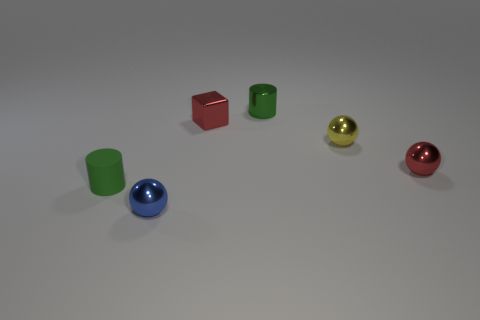Subtract all small red shiny balls. How many balls are left? 2 Add 4 red metallic spheres. How many objects exist? 10 Subtract 1 balls. How many balls are left? 2 Subtract all blocks. How many objects are left? 5 Subtract all rubber objects. Subtract all yellow metal things. How many objects are left? 4 Add 3 small yellow metallic things. How many small yellow metallic things are left? 4 Add 6 tiny balls. How many tiny balls exist? 9 Subtract 0 gray balls. How many objects are left? 6 Subtract all gray cylinders. Subtract all gray blocks. How many cylinders are left? 2 